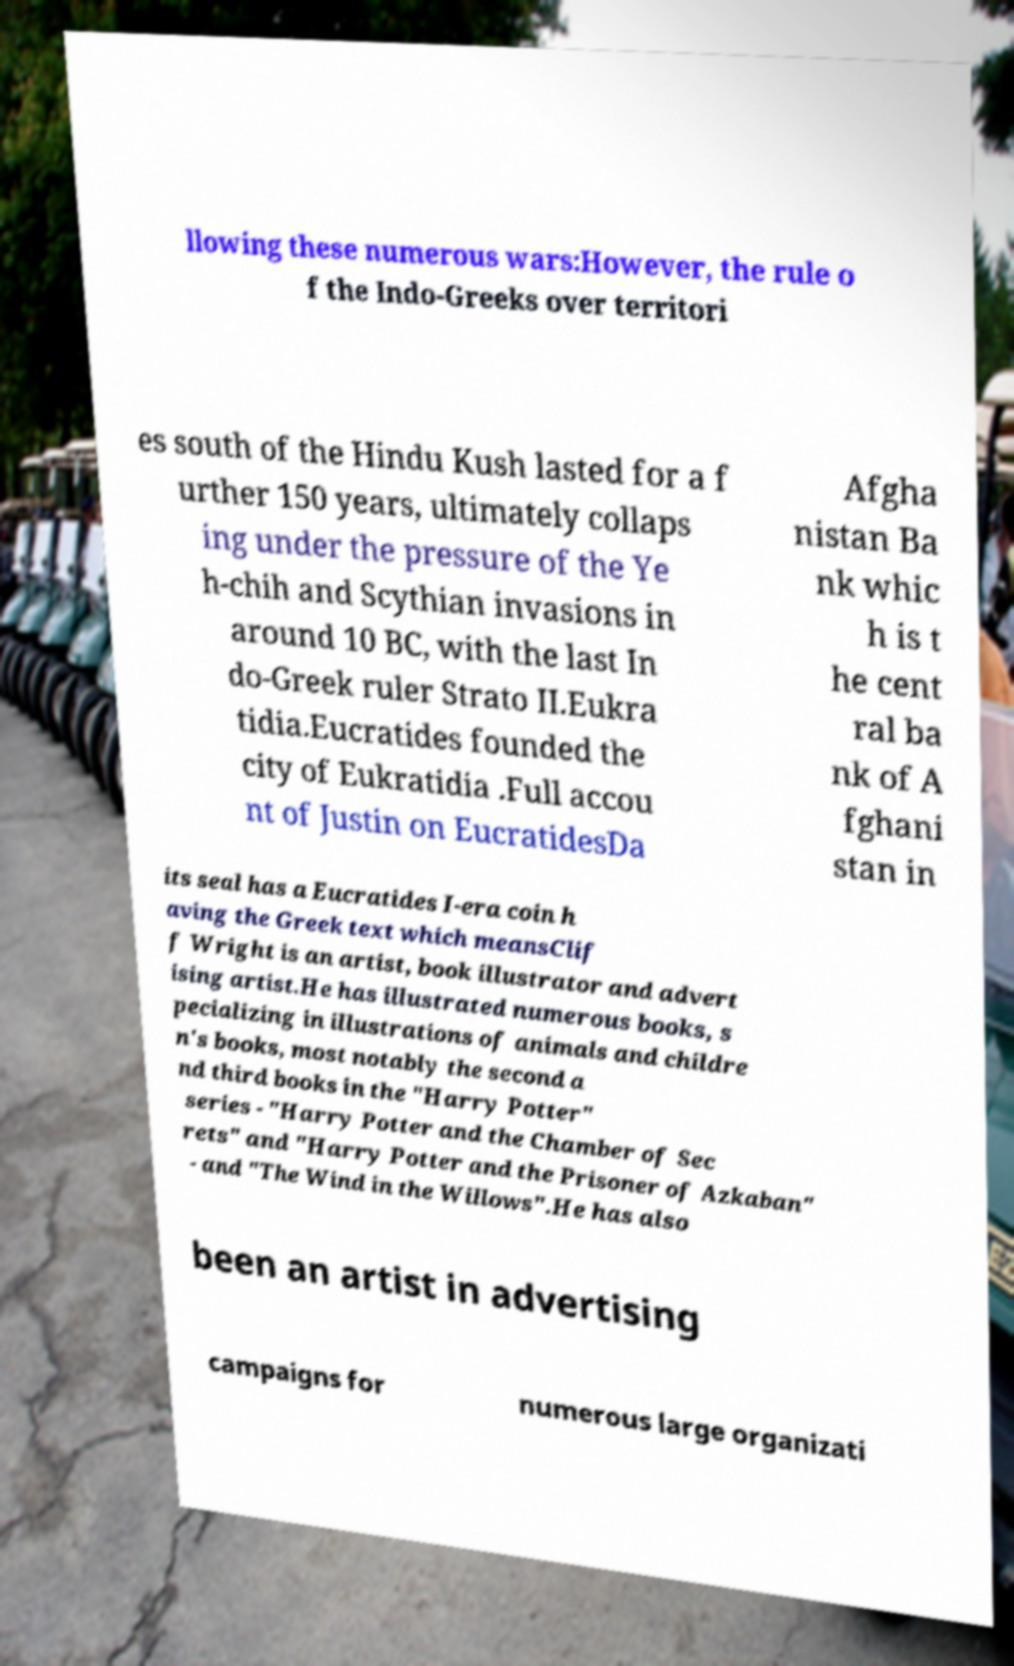Could you assist in decoding the text presented in this image and type it out clearly? llowing these numerous wars:However, the rule o f the Indo-Greeks over territori es south of the Hindu Kush lasted for a f urther 150 years, ultimately collaps ing under the pressure of the Ye h-chih and Scythian invasions in around 10 BC, with the last In do-Greek ruler Strato II.Eukra tidia.Eucratides founded the city of Eukratidia .Full accou nt of Justin on EucratidesDa Afgha nistan Ba nk whic h is t he cent ral ba nk of A fghani stan in its seal has a Eucratides I-era coin h aving the Greek text which meansClif f Wright is an artist, book illustrator and advert ising artist.He has illustrated numerous books, s pecializing in illustrations of animals and childre n's books, most notably the second a nd third books in the "Harry Potter" series - "Harry Potter and the Chamber of Sec rets" and "Harry Potter and the Prisoner of Azkaban" - and "The Wind in the Willows".He has also been an artist in advertising campaigns for numerous large organizati 